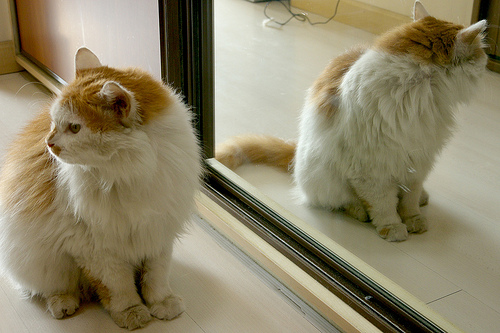<image>
Is there a cat on the mirror? No. The cat is not positioned on the mirror. They may be near each other, but the cat is not supported by or resting on top of the mirror. Is the cat in front of the mirror? Yes. The cat is positioned in front of the mirror, appearing closer to the camera viewpoint. 